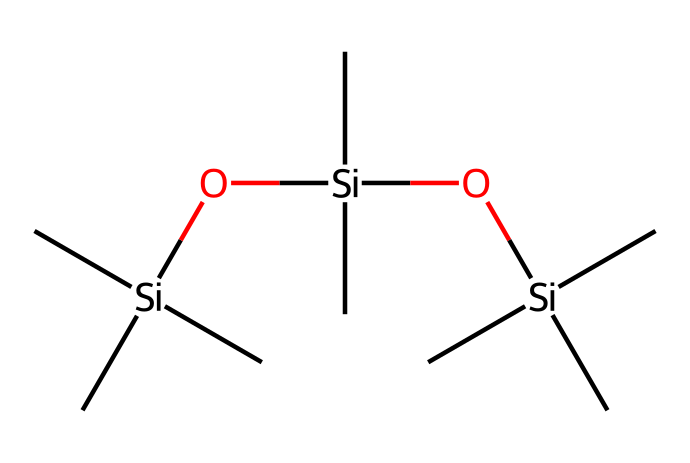What is the main element in this chemical? The provided SMILES shows a structure that contains silicon (Si) atoms. In Silly Putty's composition, silicon is the predominant element.
Answer: silicon How many silicon atoms are present? By analyzing the SMILES representation, there are three silicon (Si) atoms indicated by the presence of 'Si' appearing three times.
Answer: 3 What type of bonding is present in this chemical? The SMILES indicates multiple carbon-silicon bonds and silicon-oxygen bonds, suggesting a network of covalent bonding typical in silicones.
Answer: covalent What is the general physical behavior of this substance? Silly Putty exhibits unique behavior as a non-Newtonian fluid, demonstrating properties such as viscosity that changes under stress.
Answer: non-Newtonian Why does this compound behave as a non-Newtonian fluid? The arrangement of silicon and oxygen atoms contributes to the polymer structure, which allows the material to respond differently under varying stress conditions, a hallmark of non-Newtonian fluids.
Answer: polymer structure 